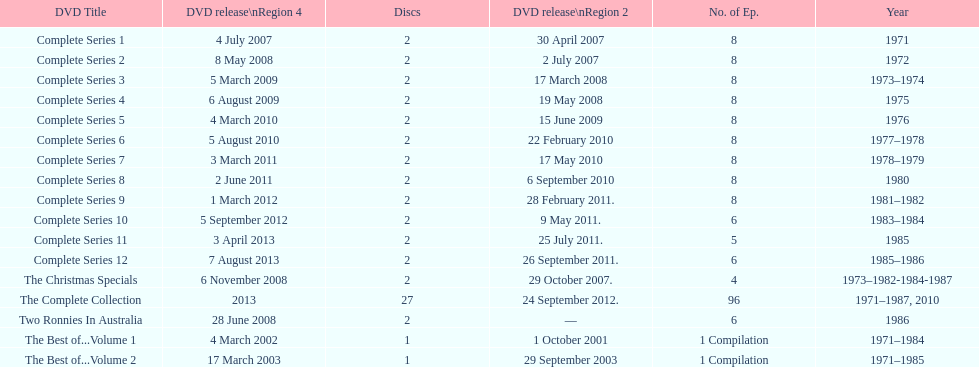Dvd shorter than 5 episodes The Christmas Specials. 